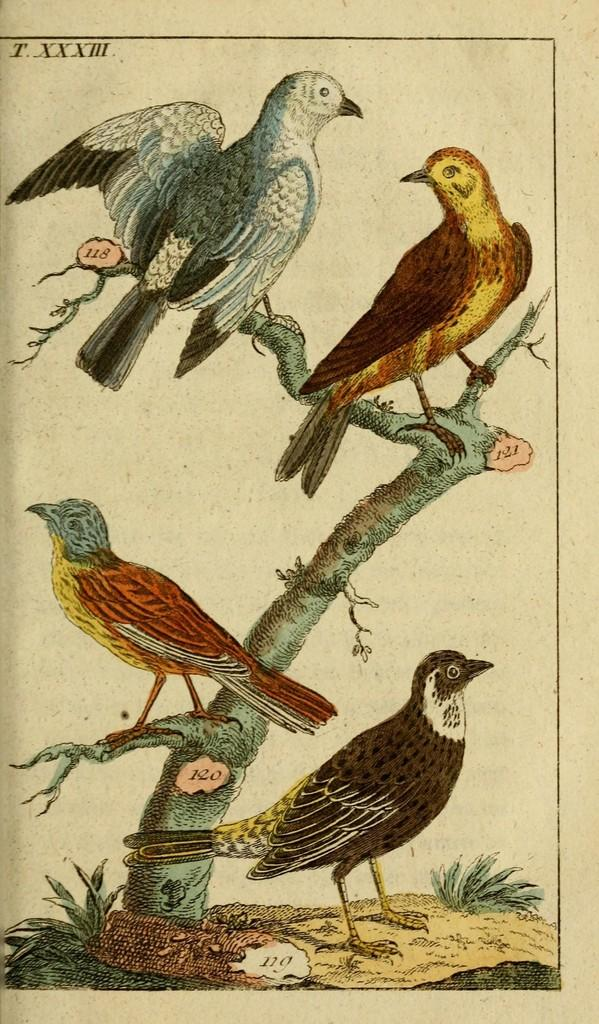How many birds are visible in the image? There are four birds in the image. Can you describe the appearance of the birds? The birds are in different colors. Where are most of the birds located in the image? Three of the birds are on a branch. What type of needle is being used by the birds in the image? There are no needles present in the image; it features four birds in different colors, with three of them on a branch. 